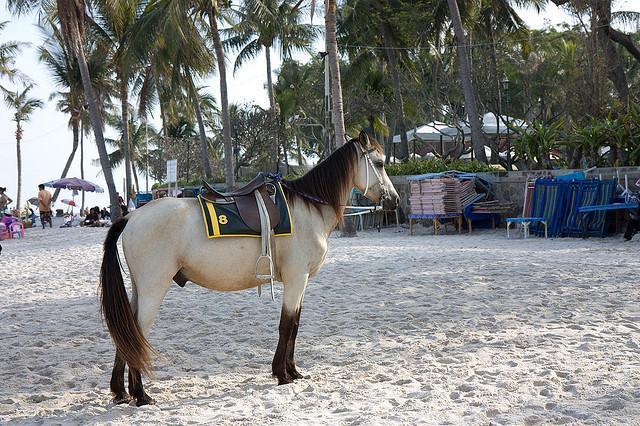How many trains are in the photo?
Give a very brief answer. 0. 